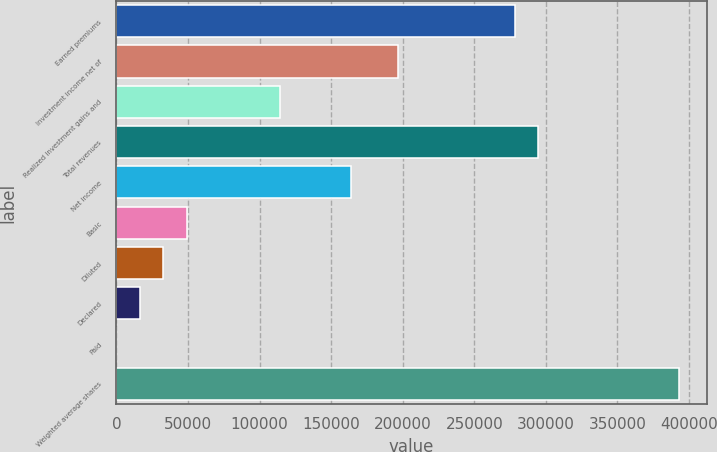<chart> <loc_0><loc_0><loc_500><loc_500><bar_chart><fcel>Earned premiums<fcel>Investment income net of<fcel>Realized investment gains and<fcel>Total revenues<fcel>Net income<fcel>Basic<fcel>Diluted<fcel>Declared<fcel>Paid<fcel>Weighted average shares<nl><fcel>278223<fcel>196393<fcel>114563<fcel>294589<fcel>163661<fcel>49099.4<fcel>32733.5<fcel>16367.5<fcel>1.61<fcel>392784<nl></chart> 